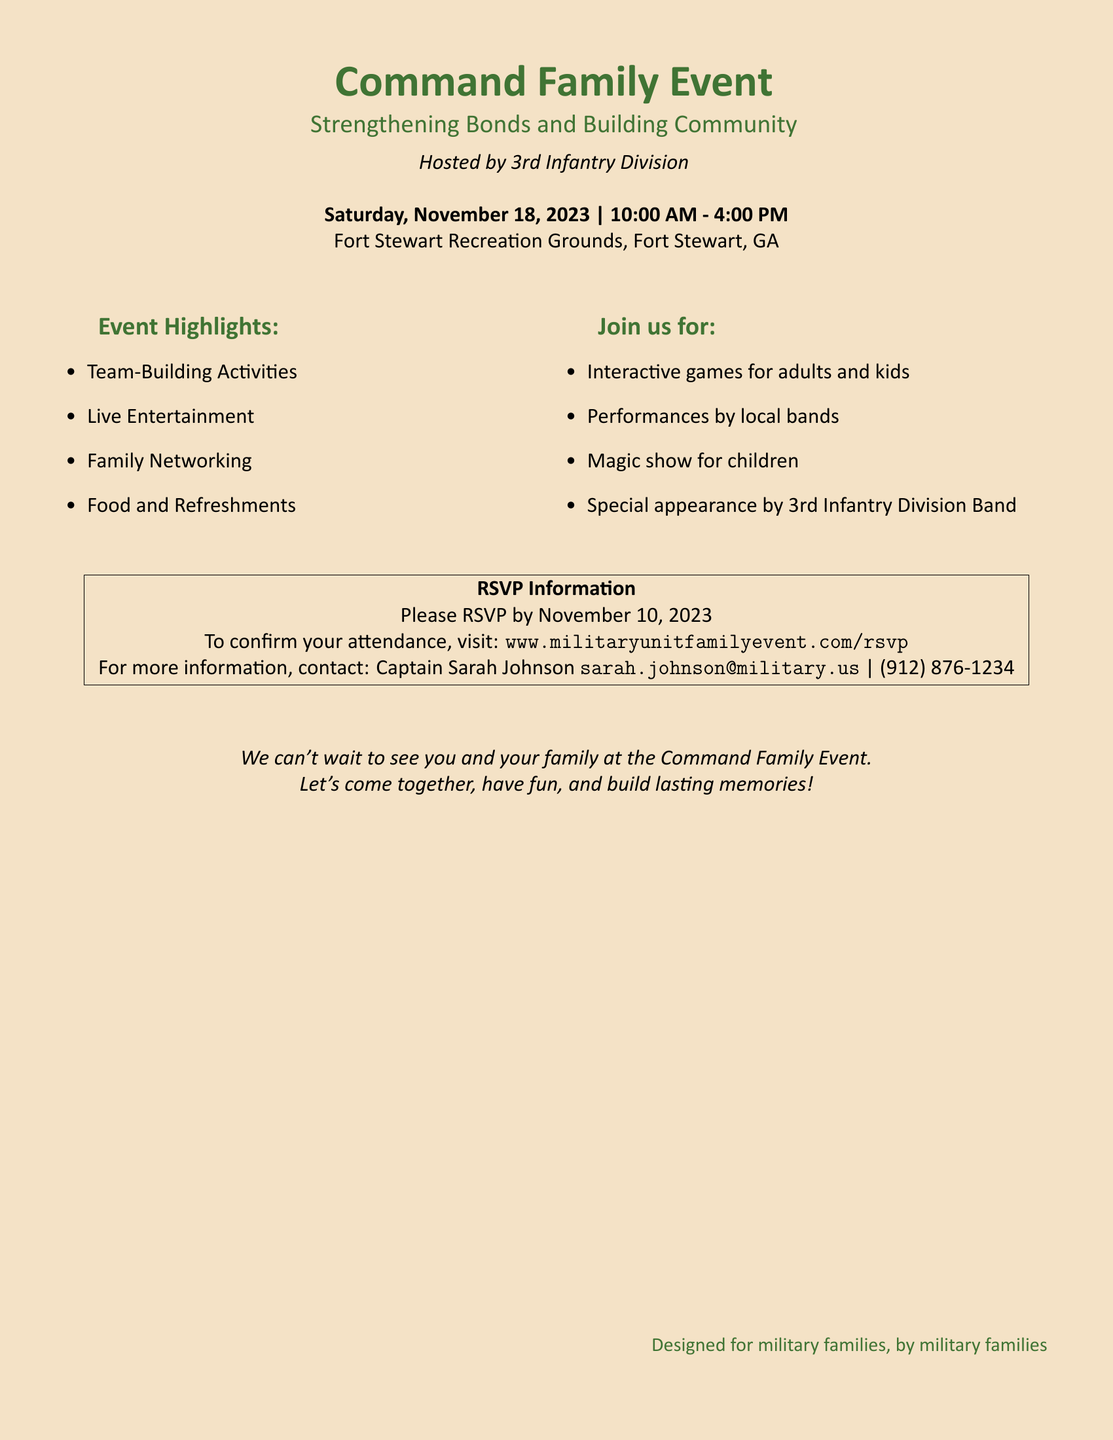What is the date of the event? The date of the event can be found in the document, which states it is on November 18, 2023.
Answer: November 18, 2023 What time does the event start? The document specifies that the event starts at 10:00 AM, which is indicated in the timing information.
Answer: 10:00 AM Who is hosting the event? The host of the event is clearly mentioned in the document as the 3rd Infantry Division.
Answer: 3rd Infantry Division What is the RSVP deadline? The document provides a specific date by which you must RSVP, which is November 10, 2023.
Answer: November 10, 2023 What type of entertainment will be at the event? The document lists various activities and entertainment, including live music and a magic show for children.
Answer: Live Entertainment How can you confirm your attendance? The document outlines the method to RSVP, which is through a specified website.
Answer: www.militaryunitfamilyevent.com/rsvp What is the purpose of the event? The document describes the event as designed to bring families together and strengthen community bonds.
Answer: Strengthening Bonds and Building Community What types of activities are planned for children? The document mentions activities specifically for children, such as interactive games and a magic show.
Answer: Magic show for children How is this event tailored for military families? The document concludes with a statement emphasizing that it is designed for military families, indicating a focus on their needs.
Answer: Designed for military families, by military families 